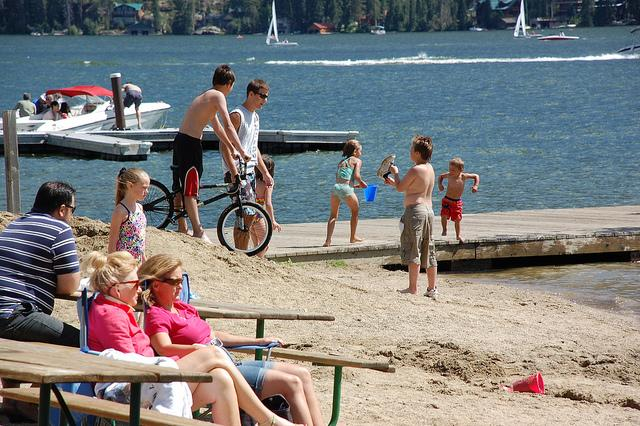Why is the boy holding up his shoe? Please explain your reasoning. disposing sand. The boy is wearing his other shoe and is one a beach so he is likely walking on the beach and getting sand in his shoes that he may want to empty. he is also tilting his held shoe at such an angle that something inside it would pour out. 